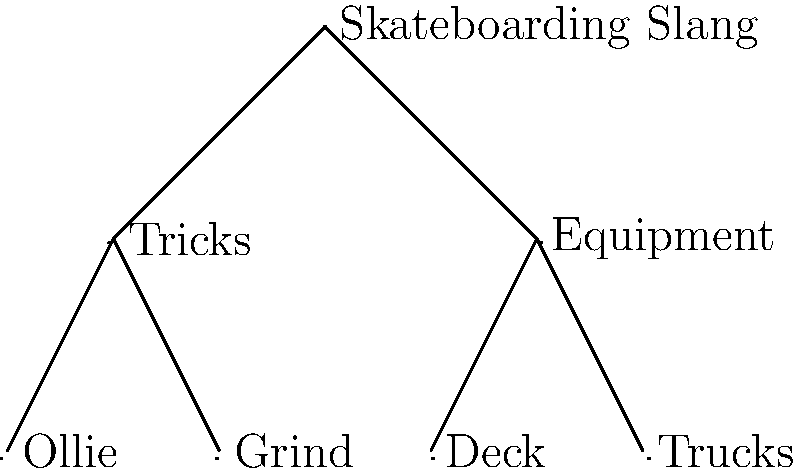Analyze the hierarchical structure of skateboarding slang terms represented in the tree diagram. Which linguistic concept does this organization most closely resemble, and how does it reflect the nature of subcultural language development? To answer this question, let's break down the analysis step-by-step:

1. Structure observation: The diagram shows a tree structure with "Skateboarding Slang" at the root, branching into two main categories: "Tricks" and "Equipment."

2. Hierarchical organization: Each main category further branches into specific terms (e.g., "Ollie" and "Grind" under "Tricks," "Deck" and "Trucks" under "Equipment").

3. Linguistic concept identification: This hierarchical structure most closely resembles a semantic field or lexical field in linguistics.

4. Semantic field definition: A semantic field is a group of words related by a common theme or concept, often organized hierarchically.

5. Subcultural language reflection: This structure reflects how subcultural languages develop by:
   a) Creating specialized vocabulary around core concepts (tricks and equipment)
   b) Organizing terms in a logical, hierarchical manner
   c) Demonstrating the depth and specificity of knowledge within the subculture

6. Language development insight: The tree structure shows how skateboarding slang evolves to cover various aspects of the activity, creating a rich, specialized vocabulary that strengthens in-group communication and identity.

7. Sociolinguistic implications: This organization highlights how subcultures develop their own linguistic systems, which can serve as markers of group membership and expertise.
Answer: Semantic field 